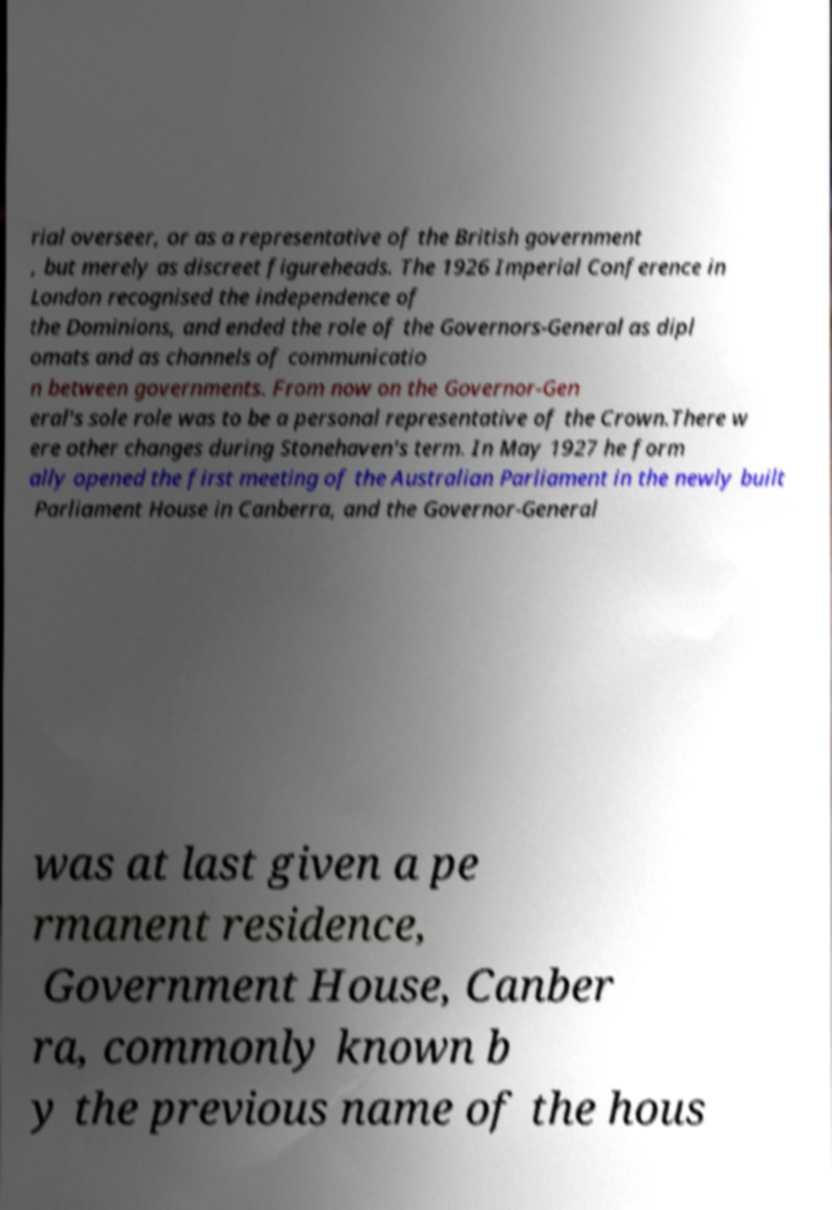Could you extract and type out the text from this image? rial overseer, or as a representative of the British government , but merely as discreet figureheads. The 1926 Imperial Conference in London recognised the independence of the Dominions, and ended the role of the Governors-General as dipl omats and as channels of communicatio n between governments. From now on the Governor-Gen eral's sole role was to be a personal representative of the Crown.There w ere other changes during Stonehaven's term. In May 1927 he form ally opened the first meeting of the Australian Parliament in the newly built Parliament House in Canberra, and the Governor-General was at last given a pe rmanent residence, Government House, Canber ra, commonly known b y the previous name of the hous 